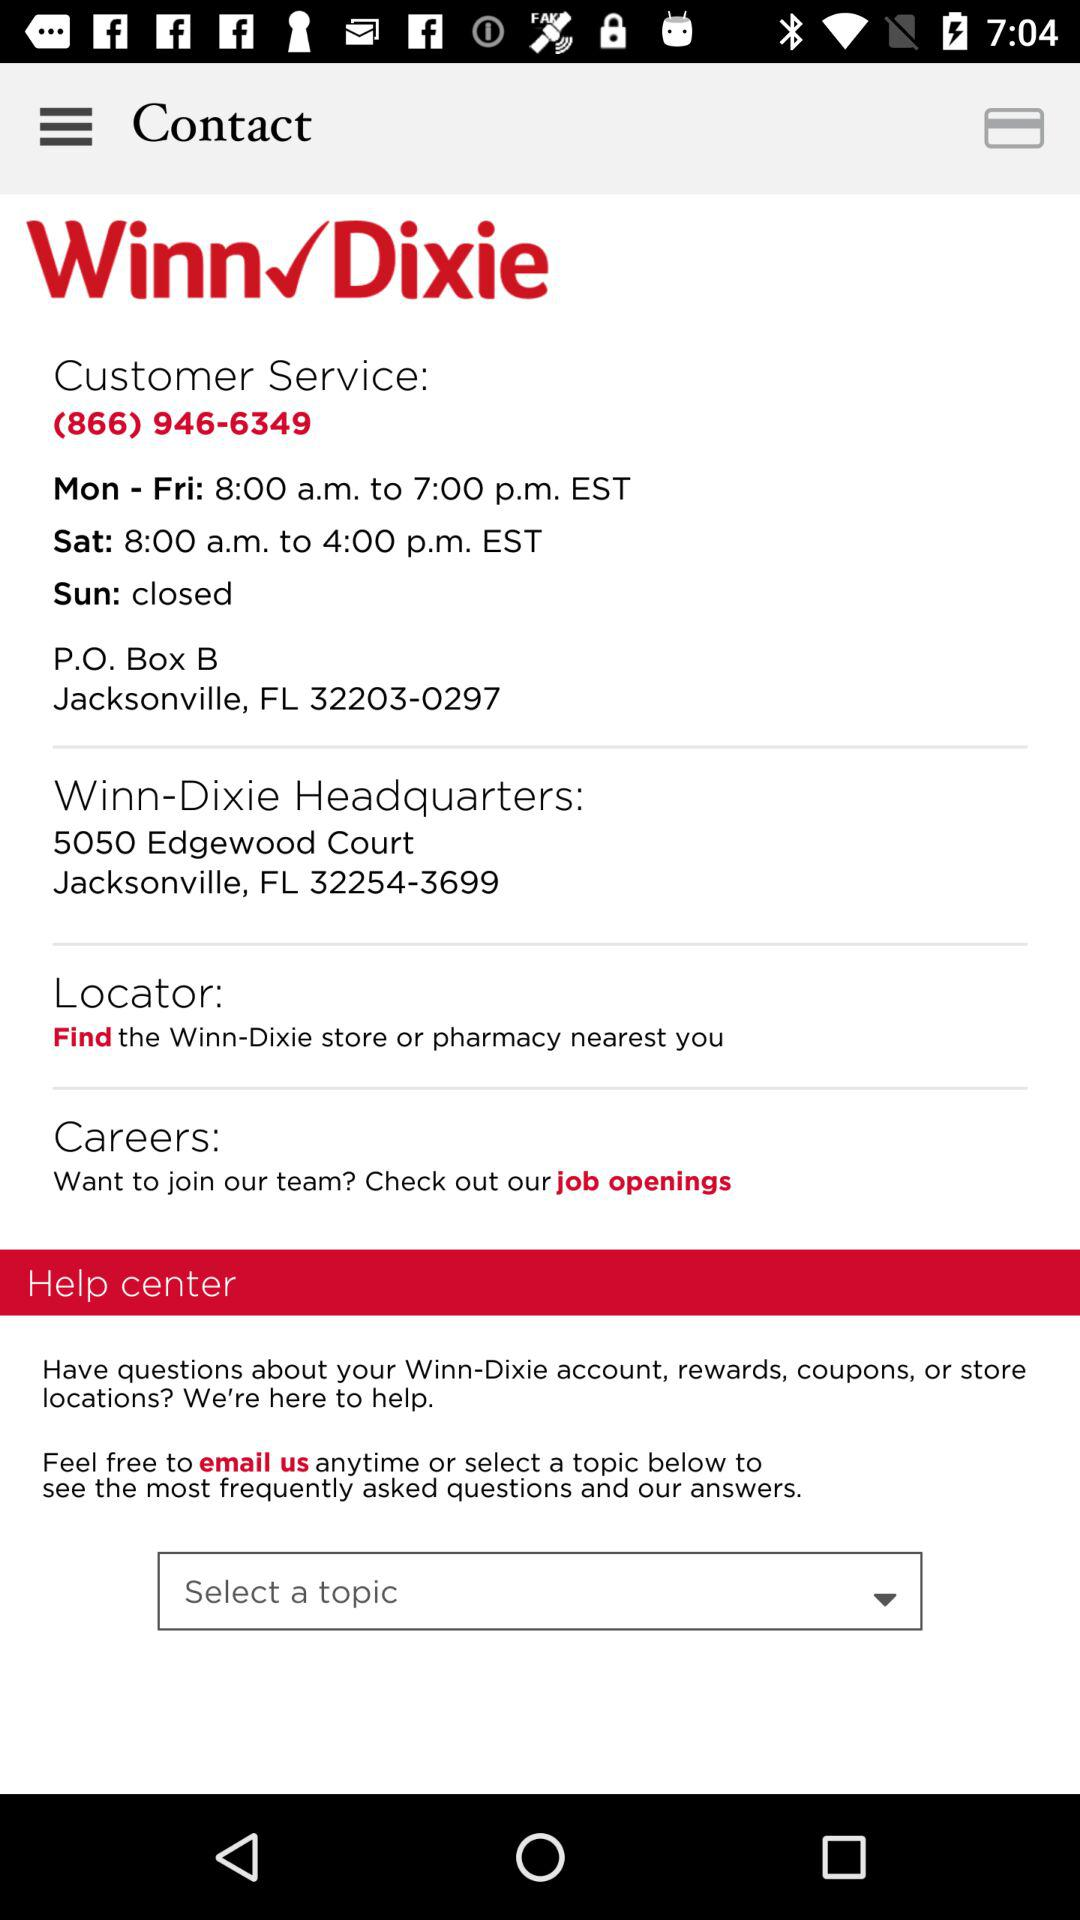What is the address of the headquarters? The address of the headquarters is 5050 Edgewood Court, Jacksonville, FL 32254-3699. 